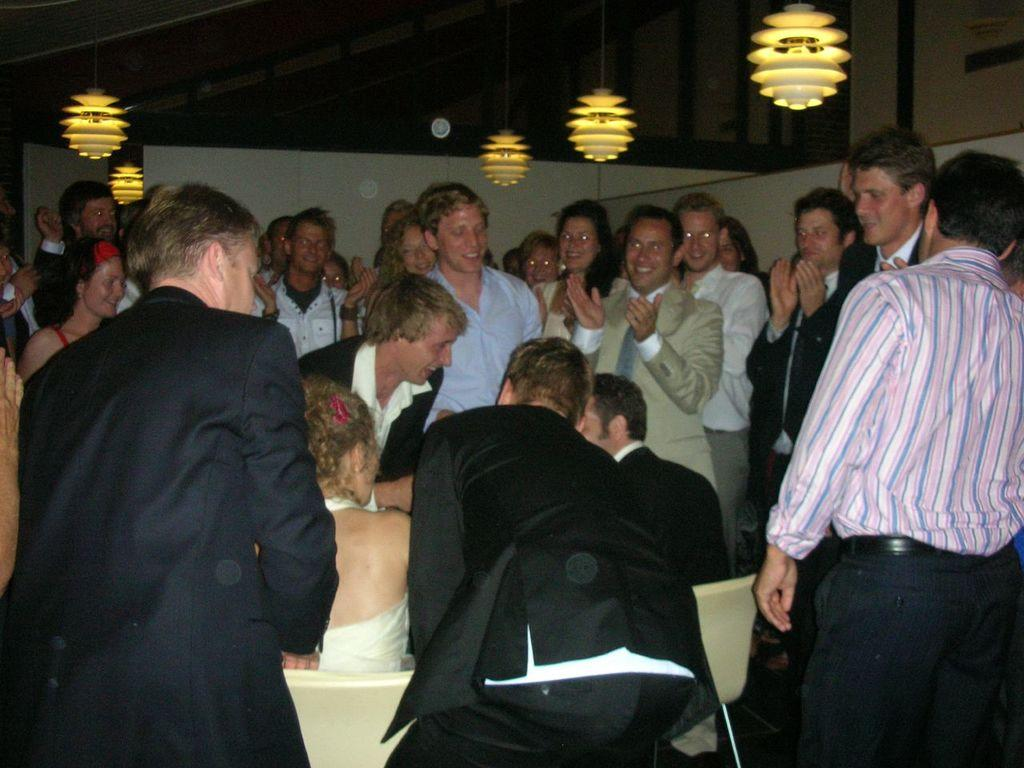What are the couple in the image doing? The couple in the image are sitting on chairs. How are the people around the couple reacting? Many people are clapping and wishing the couple. What can be seen hanging from the roof in the image? There are lights hanging down from the roof in the image. What type of tail can be seen on the couple in the image? There is no tail present on the couple in the image. 